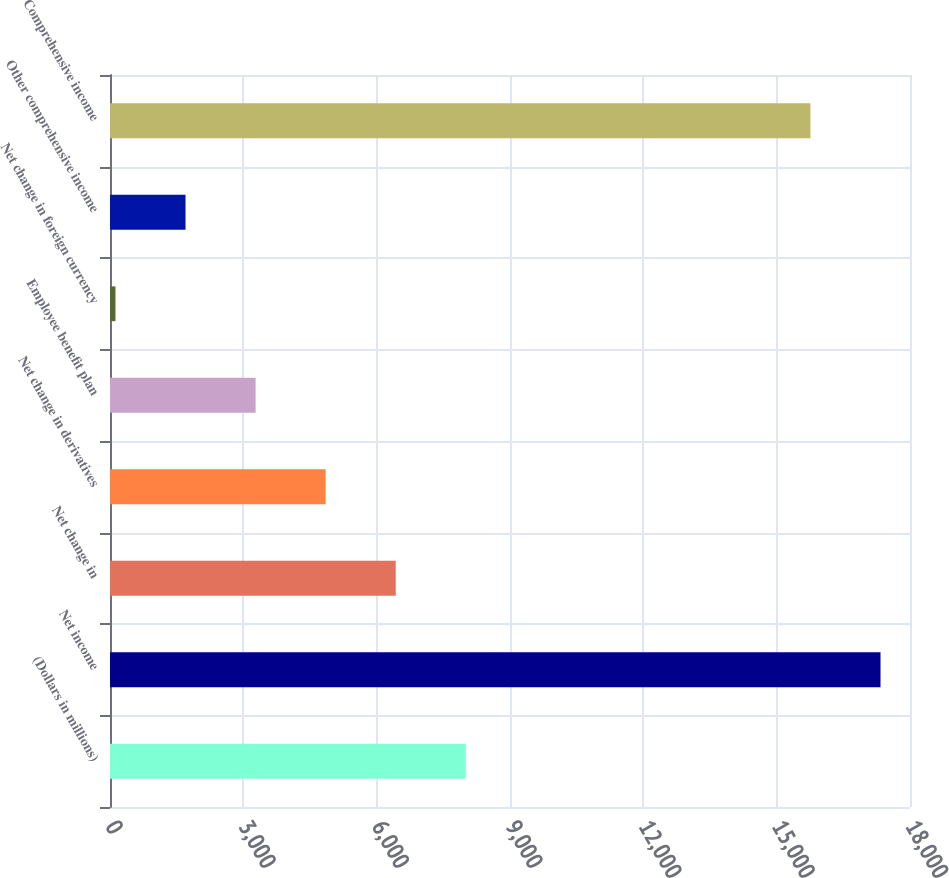Convert chart to OTSL. <chart><loc_0><loc_0><loc_500><loc_500><bar_chart><fcel>(Dollars in millions)<fcel>Net income<fcel>Net change in<fcel>Net change in derivatives<fcel>Employee benefit plan<fcel>Net change in foreign currency<fcel>Other comprehensive income<fcel>Comprehensive income<nl><fcel>8005.5<fcel>17336.5<fcel>6429<fcel>4852.5<fcel>3276<fcel>123<fcel>1699.5<fcel>15760<nl></chart> 